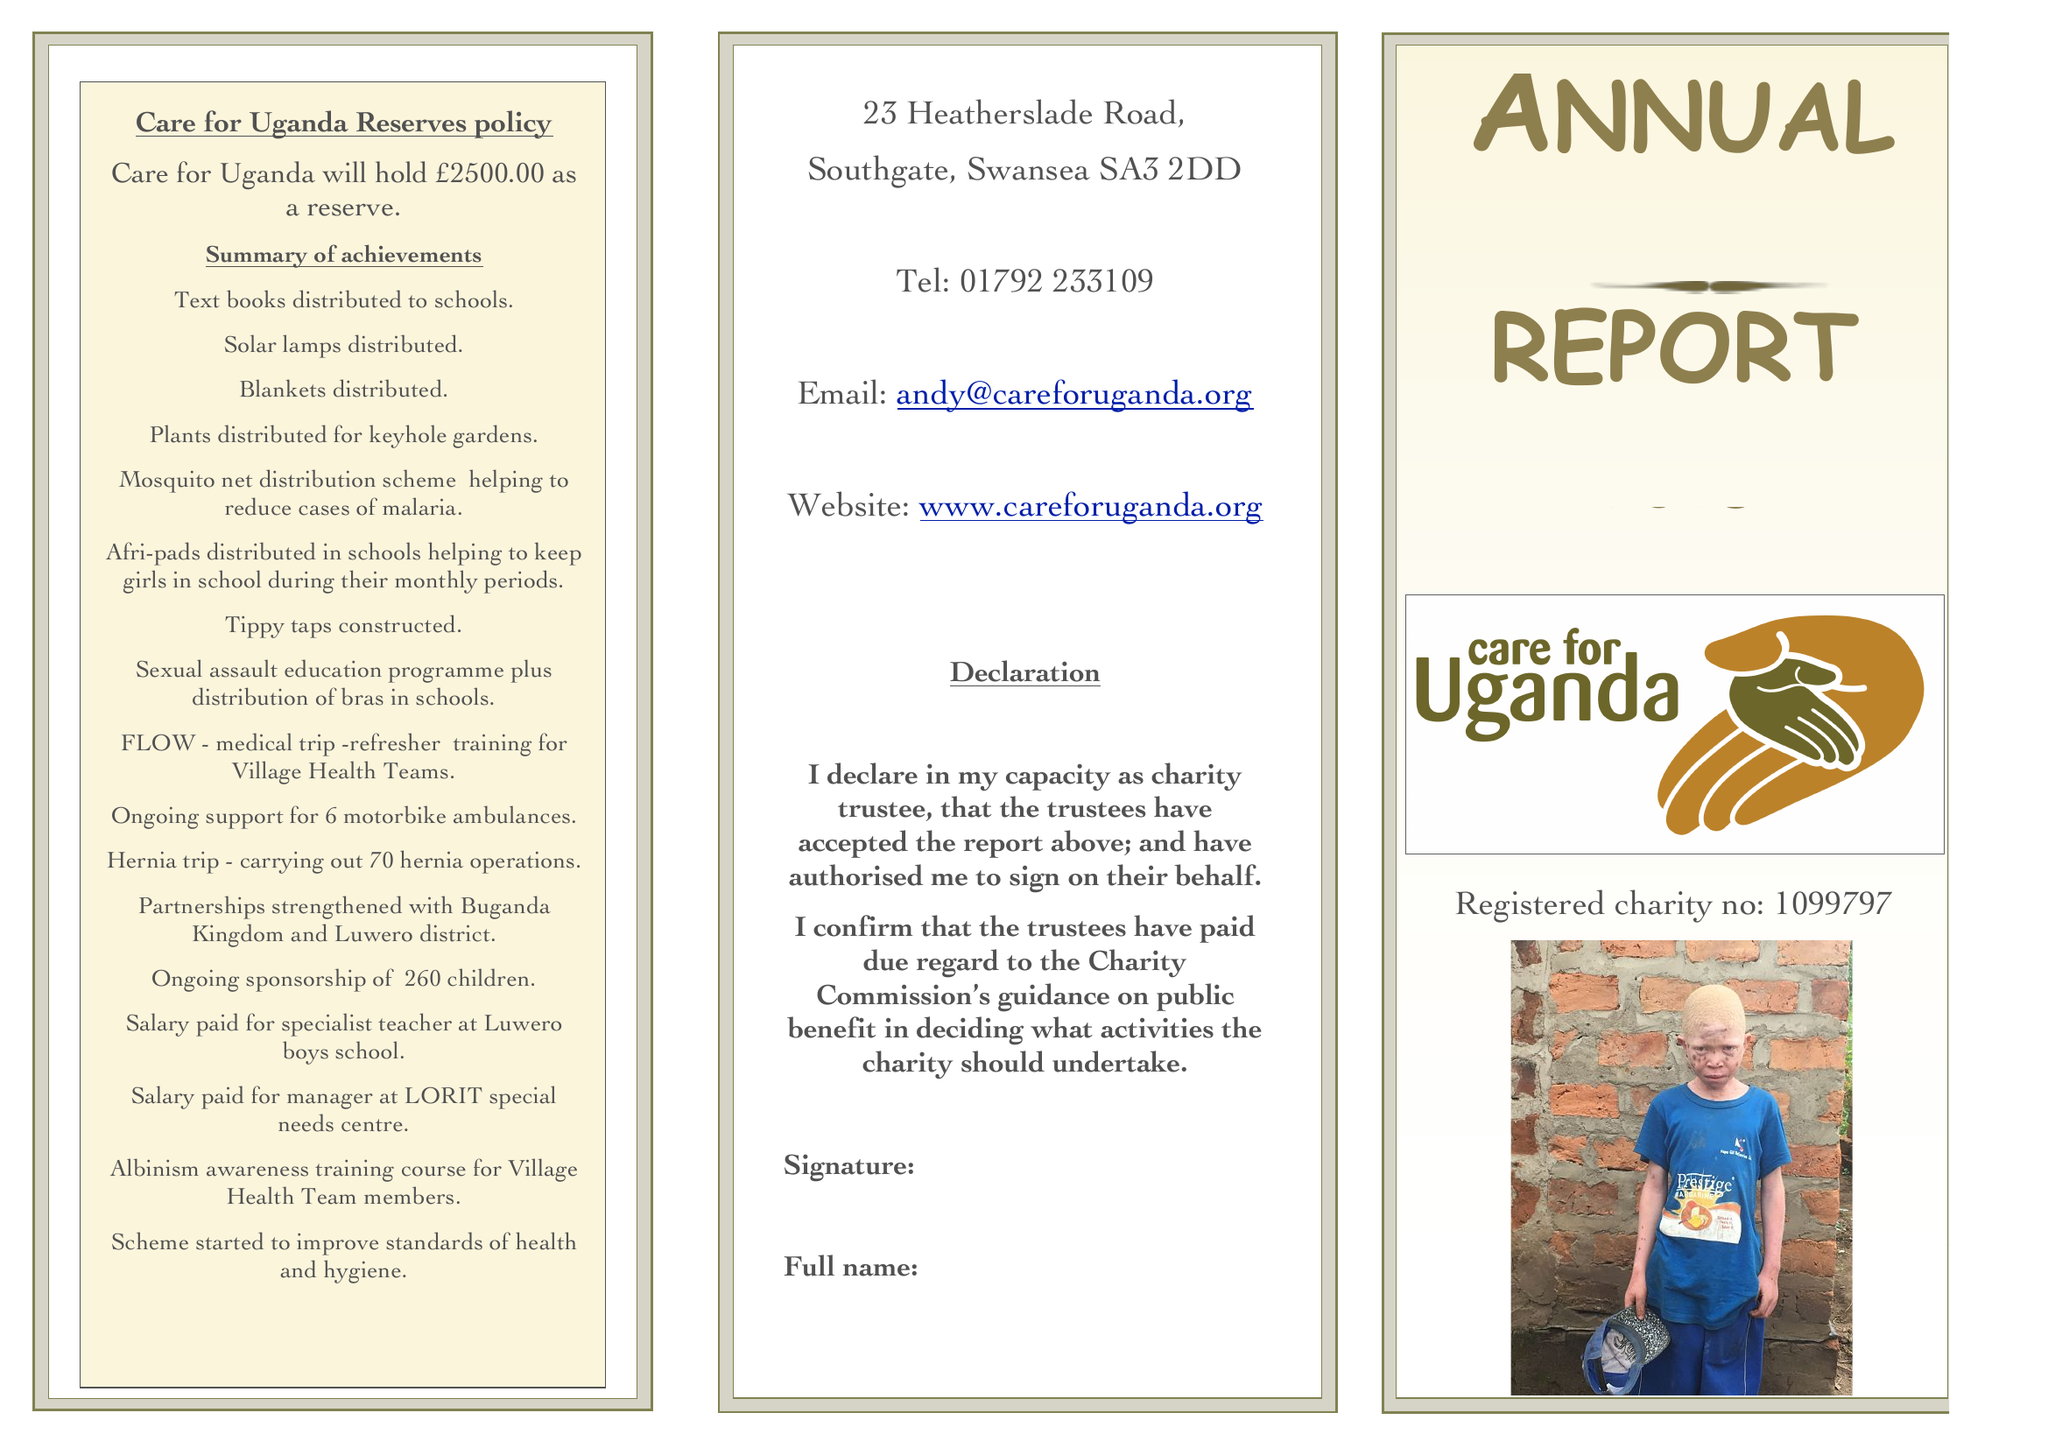What is the value for the address__post_town?
Answer the question using a single word or phrase. SWANSEA 